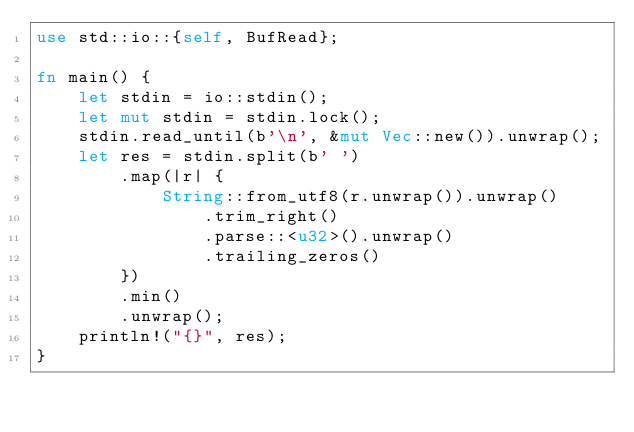Convert code to text. <code><loc_0><loc_0><loc_500><loc_500><_Rust_>use std::io::{self, BufRead};

fn main() {
    let stdin = io::stdin();
    let mut stdin = stdin.lock();
    stdin.read_until(b'\n', &mut Vec::new()).unwrap();
    let res = stdin.split(b' ')
        .map(|r| {
            String::from_utf8(r.unwrap()).unwrap()
                .trim_right()
                .parse::<u32>().unwrap()
                .trailing_zeros()
        })
        .min()
        .unwrap();
    println!("{}", res);
}</code> 